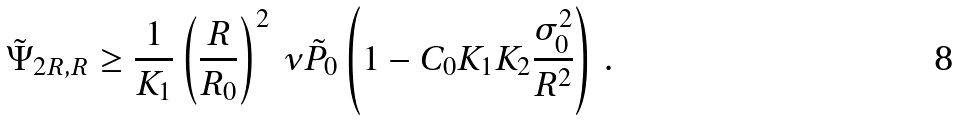Convert formula to latex. <formula><loc_0><loc_0><loc_500><loc_500>\tilde { \Psi } _ { 2 R , R } \geq \frac { 1 } { K _ { 1 } } \left ( \frac { R } { R _ { 0 } } \right ) ^ { 2 } \, \nu \tilde { P } _ { 0 } \left ( 1 - C _ { 0 } K _ { 1 } K _ { 2 } \frac { \sigma _ { 0 } ^ { 2 } } { R ^ { 2 } } \right ) \, .</formula> 